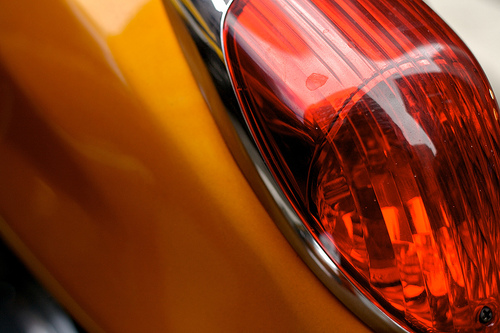<image>
Can you confirm if the lamp is under the body? No. The lamp is not positioned under the body. The vertical relationship between these objects is different. 